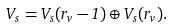Convert formula to latex. <formula><loc_0><loc_0><loc_500><loc_500>V _ { s } = V _ { s } ( { r _ { v } - 1 } ) \oplus V _ { s } ( { r _ { v } } ) .</formula> 